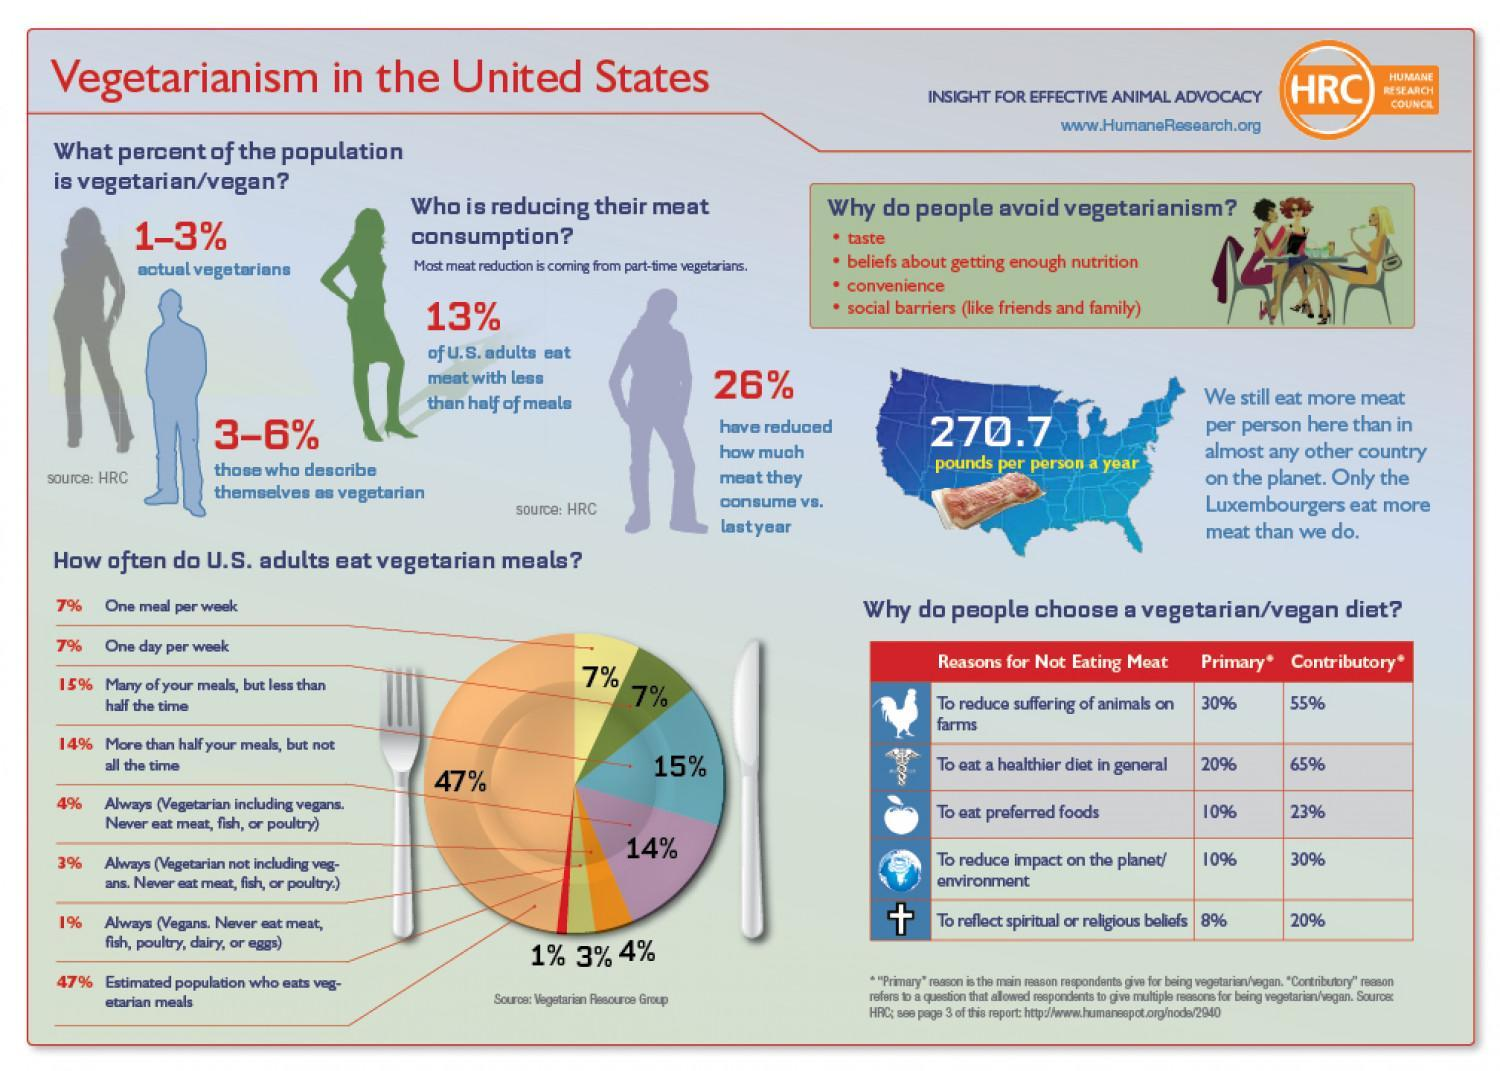How many reasons are listed to show why Americans choose a vegan diet?
Answer the question with a short phrase. 5 What percentage of Americans have reduced meat consumption from previous year? 26% What percentage of Americans declare themselves as vegetarian? 3-6% What percentage of Americans are actual vegetarians? 1-3% How many reasons are listed to show why Americans avoid vegetarian food? 4 What percentage of Americans does not eat meat with less than half of meals? 87 